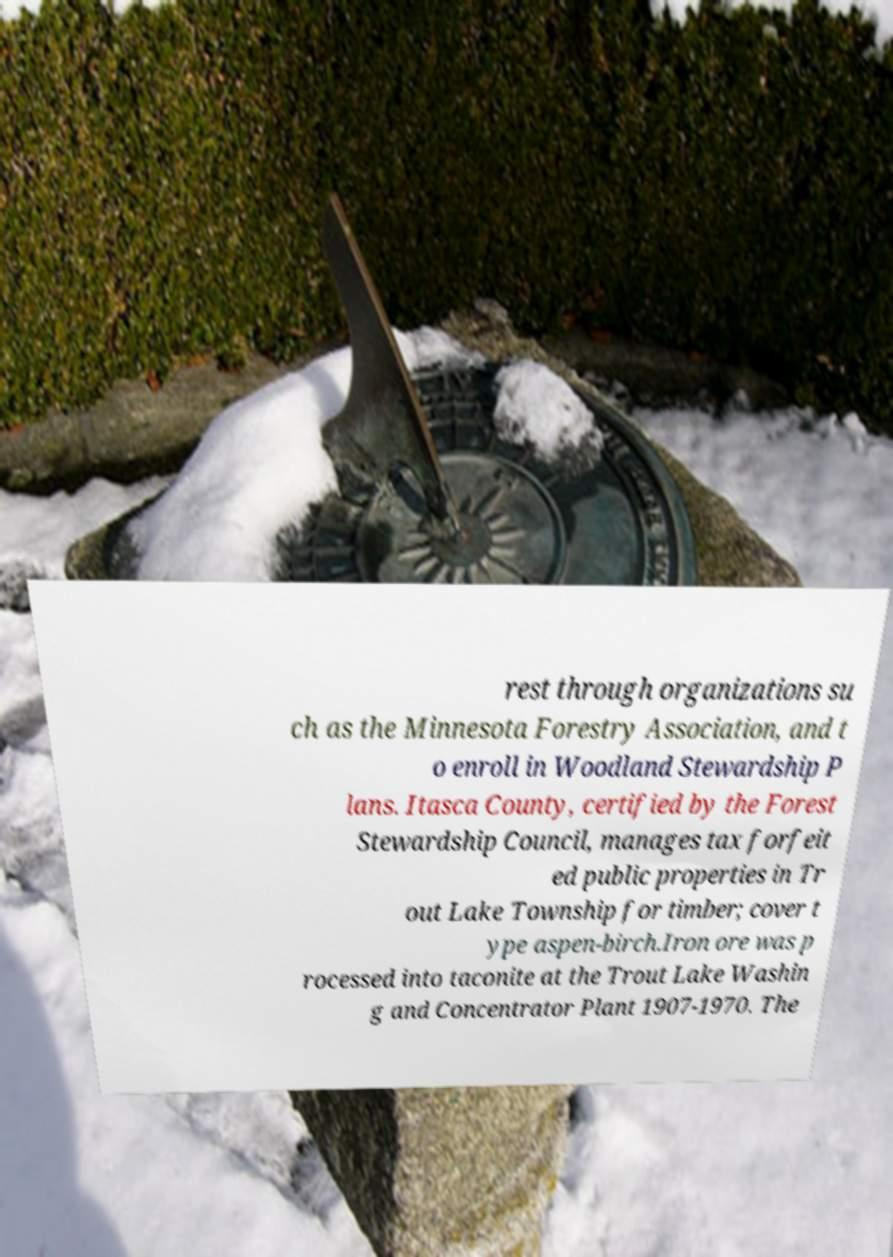Please read and relay the text visible in this image. What does it say? rest through organizations su ch as the Minnesota Forestry Association, and t o enroll in Woodland Stewardship P lans. Itasca County, certified by the Forest Stewardship Council, manages tax forfeit ed public properties in Tr out Lake Township for timber; cover t ype aspen-birch.Iron ore was p rocessed into taconite at the Trout Lake Washin g and Concentrator Plant 1907-1970. The 